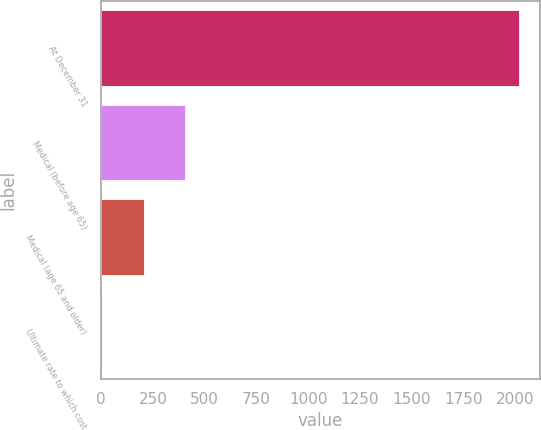Convert chart. <chart><loc_0><loc_0><loc_500><loc_500><bar_chart><fcel>At December 31<fcel>Medical (before age 65)<fcel>Medical (age 65 and older)<fcel>Ultimate rate to which cost<nl><fcel>2017<fcel>407<fcel>205.75<fcel>4.5<nl></chart> 